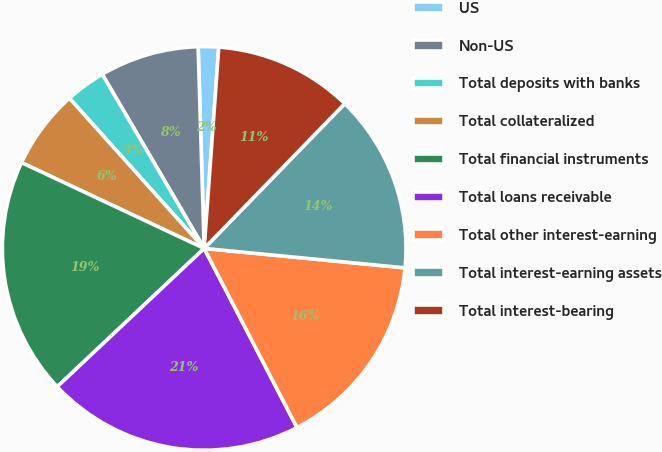<chart> <loc_0><loc_0><loc_500><loc_500><pie_chart><fcel>US<fcel>Non-US<fcel>Total deposits with banks<fcel>Total collateralized<fcel>Total financial instruments<fcel>Total loans receivable<fcel>Total other interest-earning<fcel>Total interest-earning assets<fcel>Total interest-bearing<nl><fcel>1.63%<fcel>7.95%<fcel>3.21%<fcel>6.37%<fcel>19.01%<fcel>20.59%<fcel>15.85%<fcel>14.27%<fcel>11.11%<nl></chart> 